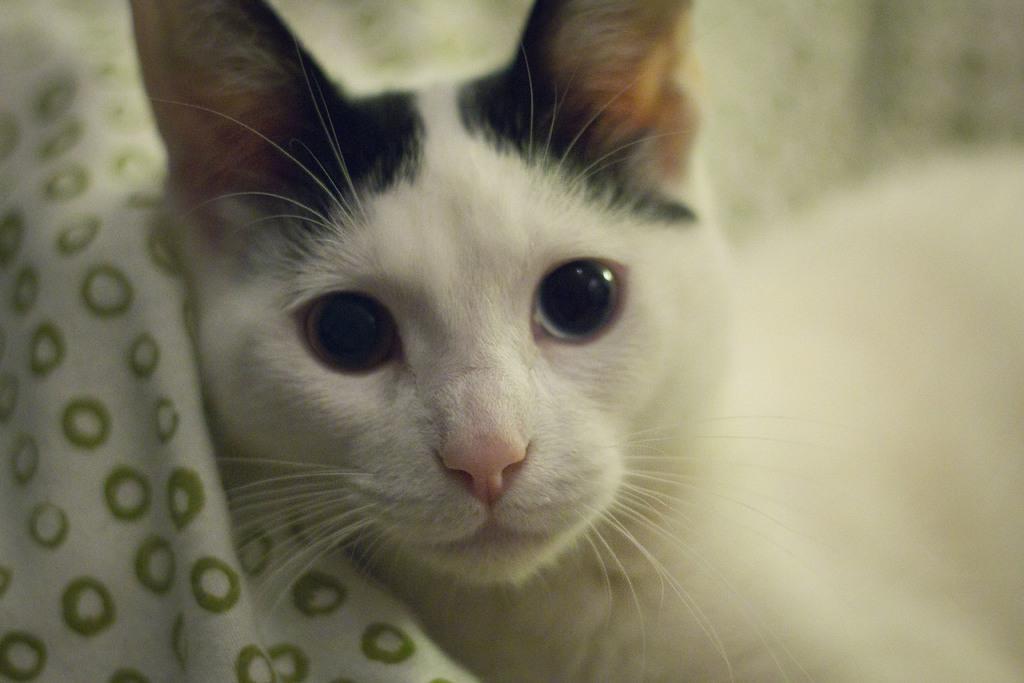Describe this image in one or two sentences. In this image there is a cat and a cloth. 